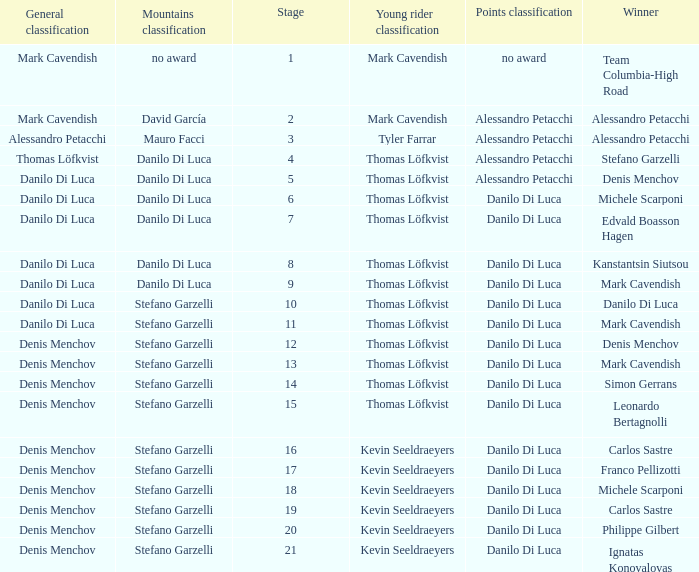When 19 is the stage who is the points classification? Danilo Di Luca. 